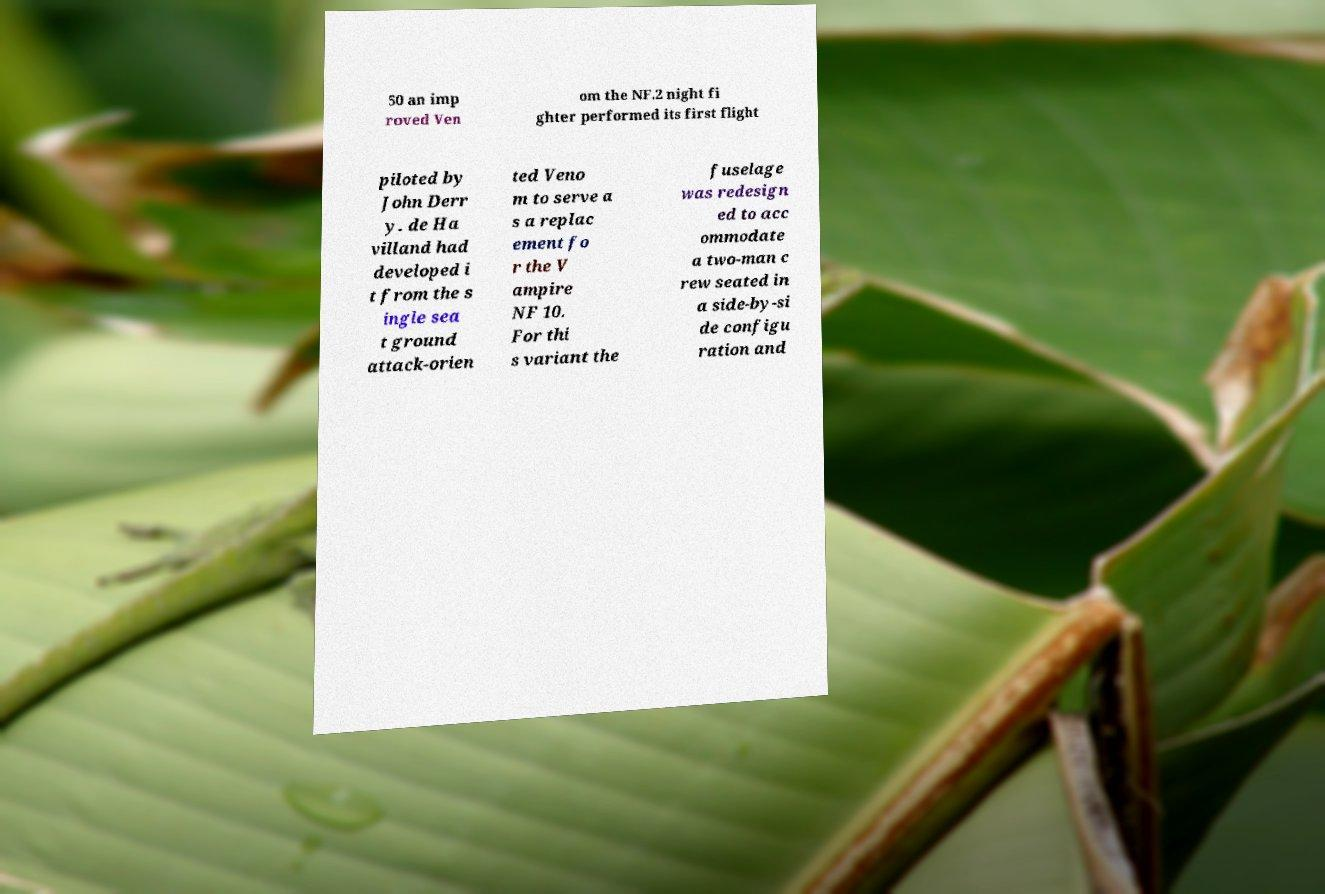Please identify and transcribe the text found in this image. 50 an imp roved Ven om the NF.2 night fi ghter performed its first flight piloted by John Derr y. de Ha villand had developed i t from the s ingle sea t ground attack-orien ted Veno m to serve a s a replac ement fo r the V ampire NF 10. For thi s variant the fuselage was redesign ed to acc ommodate a two-man c rew seated in a side-by-si de configu ration and 